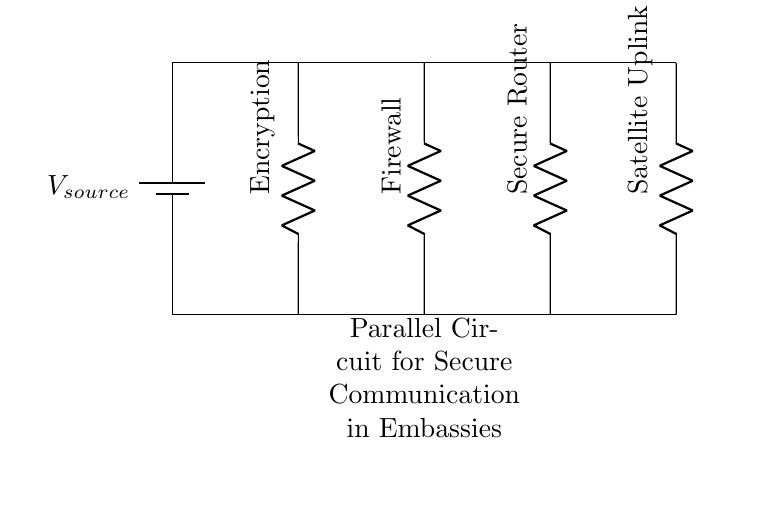What components are included in this circuit? The circuit diagram contains four components: an Encryption device, a Firewall, a Secure Router, and a Satellite Uplink, each represented as a resistor symbol in the diagram.
Answer: Encryption device, Firewall, Secure Router, Satellite Uplink What is the purpose of the Encryption device? The Encryption device's purpose is to secure communication by encoding the data before it is transmitted over the network, ensuring confidentiality and data integrity.
Answer: Secure communication How many branches are in the parallel circuit? The diagram shows four distinct branches within the parallel circuit, each corresponding to different secure communication devices.
Answer: Four Which device is closest to the power supply? The Encryption device is closest to the power supply, as it is connected to the top line parallel to the power source.
Answer: Encryption device If one component fails, what happens to the others? In a parallel circuit, if one component fails, the others continue to operate because each component has its own separate path for the current. This design enhances reliability and ensures continuous operation.
Answer: Others continue to operate What type of circuit is represented here? The diagram depicts a parallel circuit, as evidenced by the multiple branches connected alongside each other to the same source, allowing independent operation of each component.
Answer: Parallel circuit 